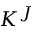<formula> <loc_0><loc_0><loc_500><loc_500>K ^ { J }</formula> 